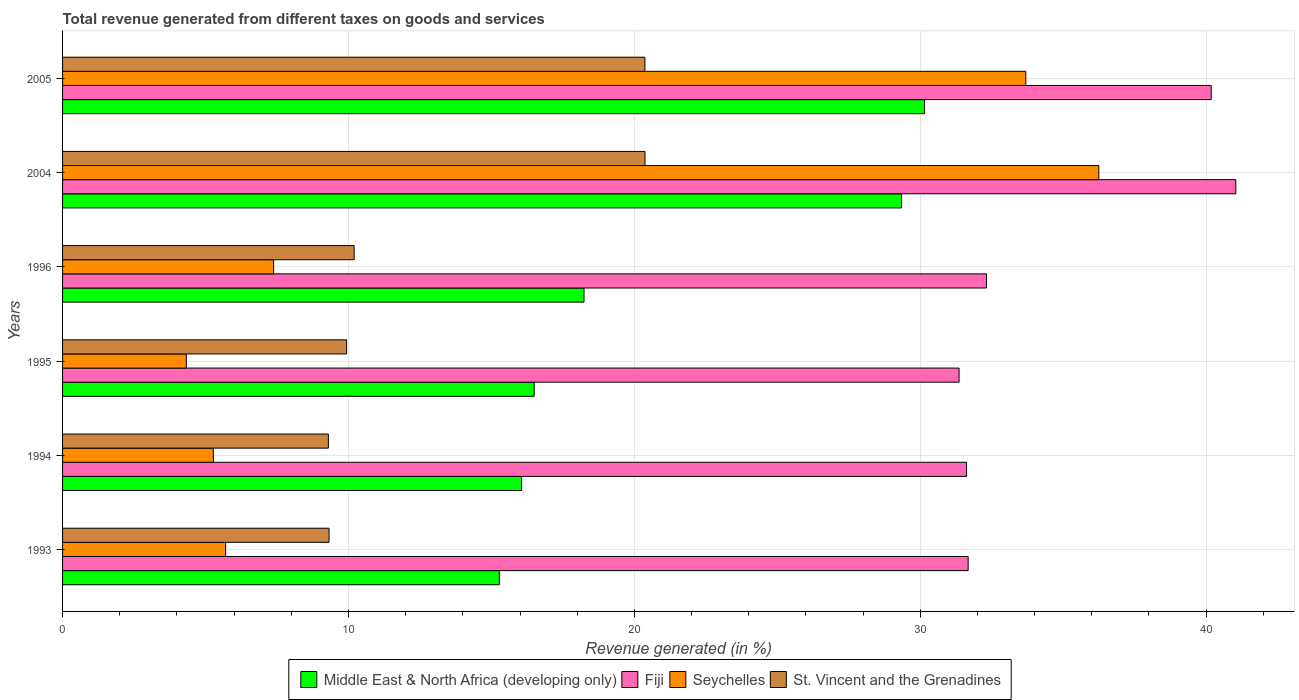How many different coloured bars are there?
Ensure brevity in your answer.  4. What is the total revenue generated in St. Vincent and the Grenadines in 1995?
Offer a terse response. 9.94. Across all years, what is the maximum total revenue generated in Middle East & North Africa (developing only)?
Provide a short and direct response. 30.15. Across all years, what is the minimum total revenue generated in Middle East & North Africa (developing only)?
Provide a succinct answer. 15.28. In which year was the total revenue generated in St. Vincent and the Grenadines maximum?
Offer a terse response. 2004. What is the total total revenue generated in St. Vincent and the Grenadines in the graph?
Your answer should be very brief. 79.5. What is the difference between the total revenue generated in St. Vincent and the Grenadines in 1996 and that in 2005?
Make the answer very short. -10.17. What is the difference between the total revenue generated in Seychelles in 1994 and the total revenue generated in Fiji in 1995?
Your answer should be very brief. -26.08. What is the average total revenue generated in Seychelles per year?
Make the answer very short. 15.44. In the year 1994, what is the difference between the total revenue generated in Fiji and total revenue generated in St. Vincent and the Grenadines?
Make the answer very short. 22.32. What is the ratio of the total revenue generated in Fiji in 1996 to that in 2004?
Provide a short and direct response. 0.79. Is the difference between the total revenue generated in Fiji in 2004 and 2005 greater than the difference between the total revenue generated in St. Vincent and the Grenadines in 2004 and 2005?
Provide a short and direct response. Yes. What is the difference between the highest and the second highest total revenue generated in Fiji?
Provide a succinct answer. 0.86. What is the difference between the highest and the lowest total revenue generated in Middle East & North Africa (developing only)?
Make the answer very short. 14.87. In how many years, is the total revenue generated in Seychelles greater than the average total revenue generated in Seychelles taken over all years?
Keep it short and to the point. 2. Is the sum of the total revenue generated in Seychelles in 1995 and 2004 greater than the maximum total revenue generated in St. Vincent and the Grenadines across all years?
Give a very brief answer. Yes. What does the 2nd bar from the top in 1995 represents?
Your answer should be very brief. Seychelles. What does the 2nd bar from the bottom in 2005 represents?
Make the answer very short. Fiji. Is it the case that in every year, the sum of the total revenue generated in Fiji and total revenue generated in St. Vincent and the Grenadines is greater than the total revenue generated in Seychelles?
Your answer should be compact. Yes. How many bars are there?
Make the answer very short. 24. How many years are there in the graph?
Give a very brief answer. 6. What is the difference between two consecutive major ticks on the X-axis?
Your response must be concise. 10. Does the graph contain any zero values?
Provide a short and direct response. No. Does the graph contain grids?
Keep it short and to the point. Yes. Where does the legend appear in the graph?
Provide a succinct answer. Bottom center. How many legend labels are there?
Your response must be concise. 4. How are the legend labels stacked?
Ensure brevity in your answer.  Horizontal. What is the title of the graph?
Your answer should be very brief. Total revenue generated from different taxes on goods and services. What is the label or title of the X-axis?
Your response must be concise. Revenue generated (in %). What is the label or title of the Y-axis?
Ensure brevity in your answer.  Years. What is the Revenue generated (in %) in Middle East & North Africa (developing only) in 1993?
Ensure brevity in your answer.  15.28. What is the Revenue generated (in %) of Fiji in 1993?
Provide a succinct answer. 31.68. What is the Revenue generated (in %) in Seychelles in 1993?
Your answer should be compact. 5.7. What is the Revenue generated (in %) in St. Vincent and the Grenadines in 1993?
Keep it short and to the point. 9.32. What is the Revenue generated (in %) of Middle East & North Africa (developing only) in 1994?
Give a very brief answer. 16.05. What is the Revenue generated (in %) of Fiji in 1994?
Provide a short and direct response. 31.62. What is the Revenue generated (in %) of Seychelles in 1994?
Offer a terse response. 5.27. What is the Revenue generated (in %) in St. Vincent and the Grenadines in 1994?
Provide a short and direct response. 9.3. What is the Revenue generated (in %) of Middle East & North Africa (developing only) in 1995?
Provide a succinct answer. 16.5. What is the Revenue generated (in %) in Fiji in 1995?
Keep it short and to the point. 31.36. What is the Revenue generated (in %) of Seychelles in 1995?
Keep it short and to the point. 4.33. What is the Revenue generated (in %) in St. Vincent and the Grenadines in 1995?
Offer a very short reply. 9.94. What is the Revenue generated (in %) of Middle East & North Africa (developing only) in 1996?
Give a very brief answer. 18.24. What is the Revenue generated (in %) in Fiji in 1996?
Provide a short and direct response. 32.32. What is the Revenue generated (in %) of Seychelles in 1996?
Your response must be concise. 7.38. What is the Revenue generated (in %) of St. Vincent and the Grenadines in 1996?
Provide a succinct answer. 10.2. What is the Revenue generated (in %) in Middle East & North Africa (developing only) in 2004?
Your response must be concise. 29.35. What is the Revenue generated (in %) in Fiji in 2004?
Provide a succinct answer. 41.04. What is the Revenue generated (in %) of Seychelles in 2004?
Your response must be concise. 36.25. What is the Revenue generated (in %) of St. Vincent and the Grenadines in 2004?
Ensure brevity in your answer.  20.37. What is the Revenue generated (in %) of Middle East & North Africa (developing only) in 2005?
Offer a terse response. 30.15. What is the Revenue generated (in %) in Fiji in 2005?
Give a very brief answer. 40.18. What is the Revenue generated (in %) in Seychelles in 2005?
Give a very brief answer. 33.69. What is the Revenue generated (in %) of St. Vincent and the Grenadines in 2005?
Provide a short and direct response. 20.37. Across all years, what is the maximum Revenue generated (in %) in Middle East & North Africa (developing only)?
Provide a short and direct response. 30.15. Across all years, what is the maximum Revenue generated (in %) in Fiji?
Make the answer very short. 41.04. Across all years, what is the maximum Revenue generated (in %) of Seychelles?
Offer a very short reply. 36.25. Across all years, what is the maximum Revenue generated (in %) in St. Vincent and the Grenadines?
Your answer should be compact. 20.37. Across all years, what is the minimum Revenue generated (in %) in Middle East & North Africa (developing only)?
Provide a succinct answer. 15.28. Across all years, what is the minimum Revenue generated (in %) in Fiji?
Keep it short and to the point. 31.36. Across all years, what is the minimum Revenue generated (in %) of Seychelles?
Ensure brevity in your answer.  4.33. Across all years, what is the minimum Revenue generated (in %) of St. Vincent and the Grenadines?
Offer a very short reply. 9.3. What is the total Revenue generated (in %) of Middle East & North Africa (developing only) in the graph?
Offer a terse response. 125.57. What is the total Revenue generated (in %) in Fiji in the graph?
Give a very brief answer. 208.18. What is the total Revenue generated (in %) in Seychelles in the graph?
Your answer should be very brief. 92.63. What is the total Revenue generated (in %) of St. Vincent and the Grenadines in the graph?
Your answer should be compact. 79.5. What is the difference between the Revenue generated (in %) of Middle East & North Africa (developing only) in 1993 and that in 1994?
Make the answer very short. -0.78. What is the difference between the Revenue generated (in %) in Fiji in 1993 and that in 1994?
Your answer should be compact. 0.06. What is the difference between the Revenue generated (in %) in Seychelles in 1993 and that in 1994?
Keep it short and to the point. 0.43. What is the difference between the Revenue generated (in %) in St. Vincent and the Grenadines in 1993 and that in 1994?
Offer a terse response. 0.02. What is the difference between the Revenue generated (in %) of Middle East & North Africa (developing only) in 1993 and that in 1995?
Your answer should be compact. -1.22. What is the difference between the Revenue generated (in %) in Fiji in 1993 and that in 1995?
Ensure brevity in your answer.  0.32. What is the difference between the Revenue generated (in %) in Seychelles in 1993 and that in 1995?
Offer a terse response. 1.37. What is the difference between the Revenue generated (in %) in St. Vincent and the Grenadines in 1993 and that in 1995?
Offer a terse response. -0.61. What is the difference between the Revenue generated (in %) in Middle East & North Africa (developing only) in 1993 and that in 1996?
Make the answer very short. -2.96. What is the difference between the Revenue generated (in %) of Fiji in 1993 and that in 1996?
Offer a very short reply. -0.64. What is the difference between the Revenue generated (in %) of Seychelles in 1993 and that in 1996?
Your answer should be very brief. -1.68. What is the difference between the Revenue generated (in %) of St. Vincent and the Grenadines in 1993 and that in 1996?
Give a very brief answer. -0.88. What is the difference between the Revenue generated (in %) in Middle East & North Africa (developing only) in 1993 and that in 2004?
Ensure brevity in your answer.  -14.07. What is the difference between the Revenue generated (in %) of Fiji in 1993 and that in 2004?
Ensure brevity in your answer.  -9.36. What is the difference between the Revenue generated (in %) in Seychelles in 1993 and that in 2004?
Ensure brevity in your answer.  -30.54. What is the difference between the Revenue generated (in %) in St. Vincent and the Grenadines in 1993 and that in 2004?
Offer a terse response. -11.05. What is the difference between the Revenue generated (in %) in Middle East & North Africa (developing only) in 1993 and that in 2005?
Offer a very short reply. -14.87. What is the difference between the Revenue generated (in %) of Fiji in 1993 and that in 2005?
Ensure brevity in your answer.  -8.5. What is the difference between the Revenue generated (in %) of Seychelles in 1993 and that in 2005?
Offer a terse response. -27.99. What is the difference between the Revenue generated (in %) in St. Vincent and the Grenadines in 1993 and that in 2005?
Provide a short and direct response. -11.05. What is the difference between the Revenue generated (in %) of Middle East & North Africa (developing only) in 1994 and that in 1995?
Ensure brevity in your answer.  -0.44. What is the difference between the Revenue generated (in %) in Fiji in 1994 and that in 1995?
Your answer should be compact. 0.26. What is the difference between the Revenue generated (in %) in Seychelles in 1994 and that in 1995?
Make the answer very short. 0.95. What is the difference between the Revenue generated (in %) in St. Vincent and the Grenadines in 1994 and that in 1995?
Provide a short and direct response. -0.64. What is the difference between the Revenue generated (in %) in Middle East & North Africa (developing only) in 1994 and that in 1996?
Make the answer very short. -2.19. What is the difference between the Revenue generated (in %) of Fiji in 1994 and that in 1996?
Your answer should be compact. -0.7. What is the difference between the Revenue generated (in %) in Seychelles in 1994 and that in 1996?
Your answer should be very brief. -2.11. What is the difference between the Revenue generated (in %) of St. Vincent and the Grenadines in 1994 and that in 1996?
Make the answer very short. -0.9. What is the difference between the Revenue generated (in %) in Middle East & North Africa (developing only) in 1994 and that in 2004?
Provide a short and direct response. -13.29. What is the difference between the Revenue generated (in %) in Fiji in 1994 and that in 2004?
Your answer should be compact. -9.42. What is the difference between the Revenue generated (in %) of Seychelles in 1994 and that in 2004?
Keep it short and to the point. -30.97. What is the difference between the Revenue generated (in %) of St. Vincent and the Grenadines in 1994 and that in 2004?
Make the answer very short. -11.07. What is the difference between the Revenue generated (in %) of Middle East & North Africa (developing only) in 1994 and that in 2005?
Provide a succinct answer. -14.1. What is the difference between the Revenue generated (in %) of Fiji in 1994 and that in 2005?
Your response must be concise. -8.56. What is the difference between the Revenue generated (in %) in Seychelles in 1994 and that in 2005?
Offer a very short reply. -28.42. What is the difference between the Revenue generated (in %) in St. Vincent and the Grenadines in 1994 and that in 2005?
Make the answer very short. -11.07. What is the difference between the Revenue generated (in %) in Middle East & North Africa (developing only) in 1995 and that in 1996?
Ensure brevity in your answer.  -1.74. What is the difference between the Revenue generated (in %) of Fiji in 1995 and that in 1996?
Your answer should be compact. -0.96. What is the difference between the Revenue generated (in %) of Seychelles in 1995 and that in 1996?
Your answer should be very brief. -3.05. What is the difference between the Revenue generated (in %) in St. Vincent and the Grenadines in 1995 and that in 1996?
Your answer should be very brief. -0.26. What is the difference between the Revenue generated (in %) of Middle East & North Africa (developing only) in 1995 and that in 2004?
Provide a short and direct response. -12.85. What is the difference between the Revenue generated (in %) of Fiji in 1995 and that in 2004?
Your answer should be very brief. -9.68. What is the difference between the Revenue generated (in %) in Seychelles in 1995 and that in 2004?
Ensure brevity in your answer.  -31.92. What is the difference between the Revenue generated (in %) in St. Vincent and the Grenadines in 1995 and that in 2004?
Ensure brevity in your answer.  -10.44. What is the difference between the Revenue generated (in %) in Middle East & North Africa (developing only) in 1995 and that in 2005?
Provide a short and direct response. -13.65. What is the difference between the Revenue generated (in %) in Fiji in 1995 and that in 2005?
Provide a short and direct response. -8.82. What is the difference between the Revenue generated (in %) of Seychelles in 1995 and that in 2005?
Your answer should be very brief. -29.36. What is the difference between the Revenue generated (in %) in St. Vincent and the Grenadines in 1995 and that in 2005?
Offer a terse response. -10.43. What is the difference between the Revenue generated (in %) of Middle East & North Africa (developing only) in 1996 and that in 2004?
Give a very brief answer. -11.11. What is the difference between the Revenue generated (in %) in Fiji in 1996 and that in 2004?
Your response must be concise. -8.72. What is the difference between the Revenue generated (in %) in Seychelles in 1996 and that in 2004?
Ensure brevity in your answer.  -28.86. What is the difference between the Revenue generated (in %) of St. Vincent and the Grenadines in 1996 and that in 2004?
Offer a very short reply. -10.17. What is the difference between the Revenue generated (in %) of Middle East & North Africa (developing only) in 1996 and that in 2005?
Ensure brevity in your answer.  -11.91. What is the difference between the Revenue generated (in %) of Fiji in 1996 and that in 2005?
Make the answer very short. -7.86. What is the difference between the Revenue generated (in %) in Seychelles in 1996 and that in 2005?
Provide a short and direct response. -26.31. What is the difference between the Revenue generated (in %) in St. Vincent and the Grenadines in 1996 and that in 2005?
Your answer should be compact. -10.17. What is the difference between the Revenue generated (in %) of Middle East & North Africa (developing only) in 2004 and that in 2005?
Provide a succinct answer. -0.8. What is the difference between the Revenue generated (in %) of Fiji in 2004 and that in 2005?
Provide a short and direct response. 0.86. What is the difference between the Revenue generated (in %) in Seychelles in 2004 and that in 2005?
Provide a short and direct response. 2.55. What is the difference between the Revenue generated (in %) of St. Vincent and the Grenadines in 2004 and that in 2005?
Provide a short and direct response. 0. What is the difference between the Revenue generated (in %) of Middle East & North Africa (developing only) in 1993 and the Revenue generated (in %) of Fiji in 1994?
Your answer should be very brief. -16.34. What is the difference between the Revenue generated (in %) of Middle East & North Africa (developing only) in 1993 and the Revenue generated (in %) of Seychelles in 1994?
Provide a short and direct response. 10. What is the difference between the Revenue generated (in %) of Middle East & North Africa (developing only) in 1993 and the Revenue generated (in %) of St. Vincent and the Grenadines in 1994?
Your answer should be very brief. 5.98. What is the difference between the Revenue generated (in %) of Fiji in 1993 and the Revenue generated (in %) of Seychelles in 1994?
Ensure brevity in your answer.  26.4. What is the difference between the Revenue generated (in %) in Fiji in 1993 and the Revenue generated (in %) in St. Vincent and the Grenadines in 1994?
Keep it short and to the point. 22.38. What is the difference between the Revenue generated (in %) of Seychelles in 1993 and the Revenue generated (in %) of St. Vincent and the Grenadines in 1994?
Provide a short and direct response. -3.59. What is the difference between the Revenue generated (in %) in Middle East & North Africa (developing only) in 1993 and the Revenue generated (in %) in Fiji in 1995?
Keep it short and to the point. -16.08. What is the difference between the Revenue generated (in %) of Middle East & North Africa (developing only) in 1993 and the Revenue generated (in %) of Seychelles in 1995?
Give a very brief answer. 10.95. What is the difference between the Revenue generated (in %) of Middle East & North Africa (developing only) in 1993 and the Revenue generated (in %) of St. Vincent and the Grenadines in 1995?
Provide a short and direct response. 5.34. What is the difference between the Revenue generated (in %) in Fiji in 1993 and the Revenue generated (in %) in Seychelles in 1995?
Provide a short and direct response. 27.35. What is the difference between the Revenue generated (in %) in Fiji in 1993 and the Revenue generated (in %) in St. Vincent and the Grenadines in 1995?
Provide a short and direct response. 21.74. What is the difference between the Revenue generated (in %) of Seychelles in 1993 and the Revenue generated (in %) of St. Vincent and the Grenadines in 1995?
Keep it short and to the point. -4.23. What is the difference between the Revenue generated (in %) in Middle East & North Africa (developing only) in 1993 and the Revenue generated (in %) in Fiji in 1996?
Make the answer very short. -17.04. What is the difference between the Revenue generated (in %) of Middle East & North Africa (developing only) in 1993 and the Revenue generated (in %) of Seychelles in 1996?
Keep it short and to the point. 7.9. What is the difference between the Revenue generated (in %) of Middle East & North Africa (developing only) in 1993 and the Revenue generated (in %) of St. Vincent and the Grenadines in 1996?
Your response must be concise. 5.08. What is the difference between the Revenue generated (in %) of Fiji in 1993 and the Revenue generated (in %) of Seychelles in 1996?
Ensure brevity in your answer.  24.29. What is the difference between the Revenue generated (in %) in Fiji in 1993 and the Revenue generated (in %) in St. Vincent and the Grenadines in 1996?
Your answer should be compact. 21.48. What is the difference between the Revenue generated (in %) of Seychelles in 1993 and the Revenue generated (in %) of St. Vincent and the Grenadines in 1996?
Provide a succinct answer. -4.5. What is the difference between the Revenue generated (in %) of Middle East & North Africa (developing only) in 1993 and the Revenue generated (in %) of Fiji in 2004?
Make the answer very short. -25.76. What is the difference between the Revenue generated (in %) of Middle East & North Africa (developing only) in 1993 and the Revenue generated (in %) of Seychelles in 2004?
Provide a succinct answer. -20.97. What is the difference between the Revenue generated (in %) in Middle East & North Africa (developing only) in 1993 and the Revenue generated (in %) in St. Vincent and the Grenadines in 2004?
Give a very brief answer. -5.09. What is the difference between the Revenue generated (in %) in Fiji in 1993 and the Revenue generated (in %) in Seychelles in 2004?
Offer a very short reply. -4.57. What is the difference between the Revenue generated (in %) in Fiji in 1993 and the Revenue generated (in %) in St. Vincent and the Grenadines in 2004?
Your answer should be very brief. 11.3. What is the difference between the Revenue generated (in %) in Seychelles in 1993 and the Revenue generated (in %) in St. Vincent and the Grenadines in 2004?
Your response must be concise. -14.67. What is the difference between the Revenue generated (in %) of Middle East & North Africa (developing only) in 1993 and the Revenue generated (in %) of Fiji in 2005?
Ensure brevity in your answer.  -24.9. What is the difference between the Revenue generated (in %) in Middle East & North Africa (developing only) in 1993 and the Revenue generated (in %) in Seychelles in 2005?
Offer a terse response. -18.41. What is the difference between the Revenue generated (in %) of Middle East & North Africa (developing only) in 1993 and the Revenue generated (in %) of St. Vincent and the Grenadines in 2005?
Your answer should be very brief. -5.09. What is the difference between the Revenue generated (in %) in Fiji in 1993 and the Revenue generated (in %) in Seychelles in 2005?
Your answer should be very brief. -2.02. What is the difference between the Revenue generated (in %) in Fiji in 1993 and the Revenue generated (in %) in St. Vincent and the Grenadines in 2005?
Keep it short and to the point. 11.31. What is the difference between the Revenue generated (in %) of Seychelles in 1993 and the Revenue generated (in %) of St. Vincent and the Grenadines in 2005?
Offer a very short reply. -14.67. What is the difference between the Revenue generated (in %) of Middle East & North Africa (developing only) in 1994 and the Revenue generated (in %) of Fiji in 1995?
Provide a short and direct response. -15.3. What is the difference between the Revenue generated (in %) in Middle East & North Africa (developing only) in 1994 and the Revenue generated (in %) in Seychelles in 1995?
Give a very brief answer. 11.73. What is the difference between the Revenue generated (in %) of Middle East & North Africa (developing only) in 1994 and the Revenue generated (in %) of St. Vincent and the Grenadines in 1995?
Provide a succinct answer. 6.12. What is the difference between the Revenue generated (in %) in Fiji in 1994 and the Revenue generated (in %) in Seychelles in 1995?
Your answer should be very brief. 27.29. What is the difference between the Revenue generated (in %) of Fiji in 1994 and the Revenue generated (in %) of St. Vincent and the Grenadines in 1995?
Give a very brief answer. 21.68. What is the difference between the Revenue generated (in %) in Seychelles in 1994 and the Revenue generated (in %) in St. Vincent and the Grenadines in 1995?
Your answer should be compact. -4.66. What is the difference between the Revenue generated (in %) of Middle East & North Africa (developing only) in 1994 and the Revenue generated (in %) of Fiji in 1996?
Your answer should be very brief. -16.26. What is the difference between the Revenue generated (in %) in Middle East & North Africa (developing only) in 1994 and the Revenue generated (in %) in Seychelles in 1996?
Make the answer very short. 8.67. What is the difference between the Revenue generated (in %) in Middle East & North Africa (developing only) in 1994 and the Revenue generated (in %) in St. Vincent and the Grenadines in 1996?
Offer a very short reply. 5.86. What is the difference between the Revenue generated (in %) in Fiji in 1994 and the Revenue generated (in %) in Seychelles in 1996?
Offer a very short reply. 24.23. What is the difference between the Revenue generated (in %) in Fiji in 1994 and the Revenue generated (in %) in St. Vincent and the Grenadines in 1996?
Your response must be concise. 21.42. What is the difference between the Revenue generated (in %) in Seychelles in 1994 and the Revenue generated (in %) in St. Vincent and the Grenadines in 1996?
Your answer should be compact. -4.93. What is the difference between the Revenue generated (in %) in Middle East & North Africa (developing only) in 1994 and the Revenue generated (in %) in Fiji in 2004?
Your response must be concise. -24.98. What is the difference between the Revenue generated (in %) of Middle East & North Africa (developing only) in 1994 and the Revenue generated (in %) of Seychelles in 2004?
Make the answer very short. -20.19. What is the difference between the Revenue generated (in %) in Middle East & North Africa (developing only) in 1994 and the Revenue generated (in %) in St. Vincent and the Grenadines in 2004?
Provide a succinct answer. -4.32. What is the difference between the Revenue generated (in %) of Fiji in 1994 and the Revenue generated (in %) of Seychelles in 2004?
Provide a short and direct response. -4.63. What is the difference between the Revenue generated (in %) in Fiji in 1994 and the Revenue generated (in %) in St. Vincent and the Grenadines in 2004?
Ensure brevity in your answer.  11.24. What is the difference between the Revenue generated (in %) of Seychelles in 1994 and the Revenue generated (in %) of St. Vincent and the Grenadines in 2004?
Provide a succinct answer. -15.1. What is the difference between the Revenue generated (in %) in Middle East & North Africa (developing only) in 1994 and the Revenue generated (in %) in Fiji in 2005?
Your answer should be compact. -24.12. What is the difference between the Revenue generated (in %) in Middle East & North Africa (developing only) in 1994 and the Revenue generated (in %) in Seychelles in 2005?
Your answer should be very brief. -17.64. What is the difference between the Revenue generated (in %) of Middle East & North Africa (developing only) in 1994 and the Revenue generated (in %) of St. Vincent and the Grenadines in 2005?
Offer a very short reply. -4.32. What is the difference between the Revenue generated (in %) in Fiji in 1994 and the Revenue generated (in %) in Seychelles in 2005?
Provide a succinct answer. -2.08. What is the difference between the Revenue generated (in %) of Fiji in 1994 and the Revenue generated (in %) of St. Vincent and the Grenadines in 2005?
Your answer should be very brief. 11.25. What is the difference between the Revenue generated (in %) of Seychelles in 1994 and the Revenue generated (in %) of St. Vincent and the Grenadines in 2005?
Provide a succinct answer. -15.1. What is the difference between the Revenue generated (in %) of Middle East & North Africa (developing only) in 1995 and the Revenue generated (in %) of Fiji in 1996?
Give a very brief answer. -15.82. What is the difference between the Revenue generated (in %) of Middle East & North Africa (developing only) in 1995 and the Revenue generated (in %) of Seychelles in 1996?
Make the answer very short. 9.11. What is the difference between the Revenue generated (in %) of Middle East & North Africa (developing only) in 1995 and the Revenue generated (in %) of St. Vincent and the Grenadines in 1996?
Your answer should be compact. 6.3. What is the difference between the Revenue generated (in %) in Fiji in 1995 and the Revenue generated (in %) in Seychelles in 1996?
Your answer should be very brief. 23.98. What is the difference between the Revenue generated (in %) in Fiji in 1995 and the Revenue generated (in %) in St. Vincent and the Grenadines in 1996?
Your answer should be very brief. 21.16. What is the difference between the Revenue generated (in %) in Seychelles in 1995 and the Revenue generated (in %) in St. Vincent and the Grenadines in 1996?
Provide a succinct answer. -5.87. What is the difference between the Revenue generated (in %) of Middle East & North Africa (developing only) in 1995 and the Revenue generated (in %) of Fiji in 2004?
Ensure brevity in your answer.  -24.54. What is the difference between the Revenue generated (in %) of Middle East & North Africa (developing only) in 1995 and the Revenue generated (in %) of Seychelles in 2004?
Keep it short and to the point. -19.75. What is the difference between the Revenue generated (in %) in Middle East & North Africa (developing only) in 1995 and the Revenue generated (in %) in St. Vincent and the Grenadines in 2004?
Give a very brief answer. -3.88. What is the difference between the Revenue generated (in %) of Fiji in 1995 and the Revenue generated (in %) of Seychelles in 2004?
Offer a terse response. -4.89. What is the difference between the Revenue generated (in %) in Fiji in 1995 and the Revenue generated (in %) in St. Vincent and the Grenadines in 2004?
Make the answer very short. 10.99. What is the difference between the Revenue generated (in %) in Seychelles in 1995 and the Revenue generated (in %) in St. Vincent and the Grenadines in 2004?
Ensure brevity in your answer.  -16.04. What is the difference between the Revenue generated (in %) in Middle East & North Africa (developing only) in 1995 and the Revenue generated (in %) in Fiji in 2005?
Ensure brevity in your answer.  -23.68. What is the difference between the Revenue generated (in %) in Middle East & North Africa (developing only) in 1995 and the Revenue generated (in %) in Seychelles in 2005?
Your response must be concise. -17.2. What is the difference between the Revenue generated (in %) in Middle East & North Africa (developing only) in 1995 and the Revenue generated (in %) in St. Vincent and the Grenadines in 2005?
Your answer should be very brief. -3.87. What is the difference between the Revenue generated (in %) of Fiji in 1995 and the Revenue generated (in %) of Seychelles in 2005?
Provide a succinct answer. -2.33. What is the difference between the Revenue generated (in %) of Fiji in 1995 and the Revenue generated (in %) of St. Vincent and the Grenadines in 2005?
Provide a short and direct response. 10.99. What is the difference between the Revenue generated (in %) of Seychelles in 1995 and the Revenue generated (in %) of St. Vincent and the Grenadines in 2005?
Your answer should be very brief. -16.04. What is the difference between the Revenue generated (in %) in Middle East & North Africa (developing only) in 1996 and the Revenue generated (in %) in Fiji in 2004?
Ensure brevity in your answer.  -22.8. What is the difference between the Revenue generated (in %) of Middle East & North Africa (developing only) in 1996 and the Revenue generated (in %) of Seychelles in 2004?
Your answer should be compact. -18.01. What is the difference between the Revenue generated (in %) of Middle East & North Africa (developing only) in 1996 and the Revenue generated (in %) of St. Vincent and the Grenadines in 2004?
Your answer should be very brief. -2.13. What is the difference between the Revenue generated (in %) of Fiji in 1996 and the Revenue generated (in %) of Seychelles in 2004?
Provide a short and direct response. -3.93. What is the difference between the Revenue generated (in %) of Fiji in 1996 and the Revenue generated (in %) of St. Vincent and the Grenadines in 2004?
Provide a succinct answer. 11.94. What is the difference between the Revenue generated (in %) of Seychelles in 1996 and the Revenue generated (in %) of St. Vincent and the Grenadines in 2004?
Offer a very short reply. -12.99. What is the difference between the Revenue generated (in %) in Middle East & North Africa (developing only) in 1996 and the Revenue generated (in %) in Fiji in 2005?
Your response must be concise. -21.94. What is the difference between the Revenue generated (in %) in Middle East & North Africa (developing only) in 1996 and the Revenue generated (in %) in Seychelles in 2005?
Give a very brief answer. -15.45. What is the difference between the Revenue generated (in %) of Middle East & North Africa (developing only) in 1996 and the Revenue generated (in %) of St. Vincent and the Grenadines in 2005?
Make the answer very short. -2.13. What is the difference between the Revenue generated (in %) in Fiji in 1996 and the Revenue generated (in %) in Seychelles in 2005?
Give a very brief answer. -1.38. What is the difference between the Revenue generated (in %) of Fiji in 1996 and the Revenue generated (in %) of St. Vincent and the Grenadines in 2005?
Give a very brief answer. 11.95. What is the difference between the Revenue generated (in %) in Seychelles in 1996 and the Revenue generated (in %) in St. Vincent and the Grenadines in 2005?
Ensure brevity in your answer.  -12.99. What is the difference between the Revenue generated (in %) of Middle East & North Africa (developing only) in 2004 and the Revenue generated (in %) of Fiji in 2005?
Offer a very short reply. -10.83. What is the difference between the Revenue generated (in %) in Middle East & North Africa (developing only) in 2004 and the Revenue generated (in %) in Seychelles in 2005?
Give a very brief answer. -4.34. What is the difference between the Revenue generated (in %) in Middle East & North Africa (developing only) in 2004 and the Revenue generated (in %) in St. Vincent and the Grenadines in 2005?
Provide a short and direct response. 8.98. What is the difference between the Revenue generated (in %) in Fiji in 2004 and the Revenue generated (in %) in Seychelles in 2005?
Your answer should be very brief. 7.35. What is the difference between the Revenue generated (in %) of Fiji in 2004 and the Revenue generated (in %) of St. Vincent and the Grenadines in 2005?
Give a very brief answer. 20.67. What is the difference between the Revenue generated (in %) in Seychelles in 2004 and the Revenue generated (in %) in St. Vincent and the Grenadines in 2005?
Ensure brevity in your answer.  15.88. What is the average Revenue generated (in %) of Middle East & North Africa (developing only) per year?
Keep it short and to the point. 20.93. What is the average Revenue generated (in %) of Fiji per year?
Provide a short and direct response. 34.7. What is the average Revenue generated (in %) in Seychelles per year?
Ensure brevity in your answer.  15.44. What is the average Revenue generated (in %) of St. Vincent and the Grenadines per year?
Offer a very short reply. 13.25. In the year 1993, what is the difference between the Revenue generated (in %) of Middle East & North Africa (developing only) and Revenue generated (in %) of Fiji?
Offer a terse response. -16.4. In the year 1993, what is the difference between the Revenue generated (in %) in Middle East & North Africa (developing only) and Revenue generated (in %) in Seychelles?
Provide a short and direct response. 9.57. In the year 1993, what is the difference between the Revenue generated (in %) in Middle East & North Africa (developing only) and Revenue generated (in %) in St. Vincent and the Grenadines?
Keep it short and to the point. 5.96. In the year 1993, what is the difference between the Revenue generated (in %) of Fiji and Revenue generated (in %) of Seychelles?
Offer a very short reply. 25.97. In the year 1993, what is the difference between the Revenue generated (in %) of Fiji and Revenue generated (in %) of St. Vincent and the Grenadines?
Provide a short and direct response. 22.35. In the year 1993, what is the difference between the Revenue generated (in %) in Seychelles and Revenue generated (in %) in St. Vincent and the Grenadines?
Keep it short and to the point. -3.62. In the year 1994, what is the difference between the Revenue generated (in %) in Middle East & North Africa (developing only) and Revenue generated (in %) in Fiji?
Ensure brevity in your answer.  -15.56. In the year 1994, what is the difference between the Revenue generated (in %) in Middle East & North Africa (developing only) and Revenue generated (in %) in Seychelles?
Your response must be concise. 10.78. In the year 1994, what is the difference between the Revenue generated (in %) of Middle East & North Africa (developing only) and Revenue generated (in %) of St. Vincent and the Grenadines?
Give a very brief answer. 6.76. In the year 1994, what is the difference between the Revenue generated (in %) of Fiji and Revenue generated (in %) of Seychelles?
Provide a succinct answer. 26.34. In the year 1994, what is the difference between the Revenue generated (in %) of Fiji and Revenue generated (in %) of St. Vincent and the Grenadines?
Your answer should be compact. 22.32. In the year 1994, what is the difference between the Revenue generated (in %) of Seychelles and Revenue generated (in %) of St. Vincent and the Grenadines?
Your answer should be very brief. -4.02. In the year 1995, what is the difference between the Revenue generated (in %) in Middle East & North Africa (developing only) and Revenue generated (in %) in Fiji?
Give a very brief answer. -14.86. In the year 1995, what is the difference between the Revenue generated (in %) of Middle East & North Africa (developing only) and Revenue generated (in %) of Seychelles?
Offer a very short reply. 12.17. In the year 1995, what is the difference between the Revenue generated (in %) in Middle East & North Africa (developing only) and Revenue generated (in %) in St. Vincent and the Grenadines?
Your answer should be very brief. 6.56. In the year 1995, what is the difference between the Revenue generated (in %) in Fiji and Revenue generated (in %) in Seychelles?
Provide a succinct answer. 27.03. In the year 1995, what is the difference between the Revenue generated (in %) in Fiji and Revenue generated (in %) in St. Vincent and the Grenadines?
Provide a succinct answer. 21.42. In the year 1995, what is the difference between the Revenue generated (in %) of Seychelles and Revenue generated (in %) of St. Vincent and the Grenadines?
Make the answer very short. -5.61. In the year 1996, what is the difference between the Revenue generated (in %) in Middle East & North Africa (developing only) and Revenue generated (in %) in Fiji?
Keep it short and to the point. -14.08. In the year 1996, what is the difference between the Revenue generated (in %) in Middle East & North Africa (developing only) and Revenue generated (in %) in Seychelles?
Give a very brief answer. 10.86. In the year 1996, what is the difference between the Revenue generated (in %) in Middle East & North Africa (developing only) and Revenue generated (in %) in St. Vincent and the Grenadines?
Keep it short and to the point. 8.04. In the year 1996, what is the difference between the Revenue generated (in %) of Fiji and Revenue generated (in %) of Seychelles?
Provide a short and direct response. 24.94. In the year 1996, what is the difference between the Revenue generated (in %) of Fiji and Revenue generated (in %) of St. Vincent and the Grenadines?
Your response must be concise. 22.12. In the year 1996, what is the difference between the Revenue generated (in %) of Seychelles and Revenue generated (in %) of St. Vincent and the Grenadines?
Your response must be concise. -2.82. In the year 2004, what is the difference between the Revenue generated (in %) in Middle East & North Africa (developing only) and Revenue generated (in %) in Fiji?
Provide a succinct answer. -11.69. In the year 2004, what is the difference between the Revenue generated (in %) of Middle East & North Africa (developing only) and Revenue generated (in %) of Seychelles?
Give a very brief answer. -6.9. In the year 2004, what is the difference between the Revenue generated (in %) of Middle East & North Africa (developing only) and Revenue generated (in %) of St. Vincent and the Grenadines?
Provide a succinct answer. 8.97. In the year 2004, what is the difference between the Revenue generated (in %) in Fiji and Revenue generated (in %) in Seychelles?
Your answer should be very brief. 4.79. In the year 2004, what is the difference between the Revenue generated (in %) of Fiji and Revenue generated (in %) of St. Vincent and the Grenadines?
Ensure brevity in your answer.  20.67. In the year 2004, what is the difference between the Revenue generated (in %) in Seychelles and Revenue generated (in %) in St. Vincent and the Grenadines?
Your answer should be very brief. 15.87. In the year 2005, what is the difference between the Revenue generated (in %) in Middle East & North Africa (developing only) and Revenue generated (in %) in Fiji?
Provide a short and direct response. -10.03. In the year 2005, what is the difference between the Revenue generated (in %) in Middle East & North Africa (developing only) and Revenue generated (in %) in Seychelles?
Provide a succinct answer. -3.54. In the year 2005, what is the difference between the Revenue generated (in %) in Middle East & North Africa (developing only) and Revenue generated (in %) in St. Vincent and the Grenadines?
Give a very brief answer. 9.78. In the year 2005, what is the difference between the Revenue generated (in %) of Fiji and Revenue generated (in %) of Seychelles?
Offer a very short reply. 6.48. In the year 2005, what is the difference between the Revenue generated (in %) in Fiji and Revenue generated (in %) in St. Vincent and the Grenadines?
Make the answer very short. 19.81. In the year 2005, what is the difference between the Revenue generated (in %) of Seychelles and Revenue generated (in %) of St. Vincent and the Grenadines?
Ensure brevity in your answer.  13.32. What is the ratio of the Revenue generated (in %) in Middle East & North Africa (developing only) in 1993 to that in 1994?
Your answer should be compact. 0.95. What is the ratio of the Revenue generated (in %) in Seychelles in 1993 to that in 1994?
Provide a short and direct response. 1.08. What is the ratio of the Revenue generated (in %) in St. Vincent and the Grenadines in 1993 to that in 1994?
Give a very brief answer. 1. What is the ratio of the Revenue generated (in %) of Middle East & North Africa (developing only) in 1993 to that in 1995?
Give a very brief answer. 0.93. What is the ratio of the Revenue generated (in %) of Seychelles in 1993 to that in 1995?
Offer a terse response. 1.32. What is the ratio of the Revenue generated (in %) in St. Vincent and the Grenadines in 1993 to that in 1995?
Offer a very short reply. 0.94. What is the ratio of the Revenue generated (in %) of Middle East & North Africa (developing only) in 1993 to that in 1996?
Ensure brevity in your answer.  0.84. What is the ratio of the Revenue generated (in %) in Fiji in 1993 to that in 1996?
Your response must be concise. 0.98. What is the ratio of the Revenue generated (in %) in Seychelles in 1993 to that in 1996?
Make the answer very short. 0.77. What is the ratio of the Revenue generated (in %) in St. Vincent and the Grenadines in 1993 to that in 1996?
Offer a terse response. 0.91. What is the ratio of the Revenue generated (in %) of Middle East & North Africa (developing only) in 1993 to that in 2004?
Offer a very short reply. 0.52. What is the ratio of the Revenue generated (in %) in Fiji in 1993 to that in 2004?
Offer a terse response. 0.77. What is the ratio of the Revenue generated (in %) in Seychelles in 1993 to that in 2004?
Ensure brevity in your answer.  0.16. What is the ratio of the Revenue generated (in %) of St. Vincent and the Grenadines in 1993 to that in 2004?
Your answer should be very brief. 0.46. What is the ratio of the Revenue generated (in %) in Middle East & North Africa (developing only) in 1993 to that in 2005?
Your answer should be very brief. 0.51. What is the ratio of the Revenue generated (in %) of Fiji in 1993 to that in 2005?
Your answer should be very brief. 0.79. What is the ratio of the Revenue generated (in %) in Seychelles in 1993 to that in 2005?
Give a very brief answer. 0.17. What is the ratio of the Revenue generated (in %) in St. Vincent and the Grenadines in 1993 to that in 2005?
Offer a terse response. 0.46. What is the ratio of the Revenue generated (in %) in Middle East & North Africa (developing only) in 1994 to that in 1995?
Your response must be concise. 0.97. What is the ratio of the Revenue generated (in %) of Fiji in 1994 to that in 1995?
Provide a succinct answer. 1.01. What is the ratio of the Revenue generated (in %) in Seychelles in 1994 to that in 1995?
Provide a succinct answer. 1.22. What is the ratio of the Revenue generated (in %) in St. Vincent and the Grenadines in 1994 to that in 1995?
Offer a very short reply. 0.94. What is the ratio of the Revenue generated (in %) of Middle East & North Africa (developing only) in 1994 to that in 1996?
Keep it short and to the point. 0.88. What is the ratio of the Revenue generated (in %) of Fiji in 1994 to that in 1996?
Ensure brevity in your answer.  0.98. What is the ratio of the Revenue generated (in %) in Seychelles in 1994 to that in 1996?
Provide a short and direct response. 0.71. What is the ratio of the Revenue generated (in %) in St. Vincent and the Grenadines in 1994 to that in 1996?
Your answer should be compact. 0.91. What is the ratio of the Revenue generated (in %) of Middle East & North Africa (developing only) in 1994 to that in 2004?
Your answer should be very brief. 0.55. What is the ratio of the Revenue generated (in %) in Fiji in 1994 to that in 2004?
Make the answer very short. 0.77. What is the ratio of the Revenue generated (in %) in Seychelles in 1994 to that in 2004?
Offer a terse response. 0.15. What is the ratio of the Revenue generated (in %) in St. Vincent and the Grenadines in 1994 to that in 2004?
Offer a very short reply. 0.46. What is the ratio of the Revenue generated (in %) of Middle East & North Africa (developing only) in 1994 to that in 2005?
Provide a short and direct response. 0.53. What is the ratio of the Revenue generated (in %) of Fiji in 1994 to that in 2005?
Offer a terse response. 0.79. What is the ratio of the Revenue generated (in %) of Seychelles in 1994 to that in 2005?
Provide a short and direct response. 0.16. What is the ratio of the Revenue generated (in %) of St. Vincent and the Grenadines in 1994 to that in 2005?
Offer a terse response. 0.46. What is the ratio of the Revenue generated (in %) of Middle East & North Africa (developing only) in 1995 to that in 1996?
Ensure brevity in your answer.  0.9. What is the ratio of the Revenue generated (in %) in Fiji in 1995 to that in 1996?
Your answer should be very brief. 0.97. What is the ratio of the Revenue generated (in %) in Seychelles in 1995 to that in 1996?
Give a very brief answer. 0.59. What is the ratio of the Revenue generated (in %) in St. Vincent and the Grenadines in 1995 to that in 1996?
Offer a very short reply. 0.97. What is the ratio of the Revenue generated (in %) of Middle East & North Africa (developing only) in 1995 to that in 2004?
Give a very brief answer. 0.56. What is the ratio of the Revenue generated (in %) of Fiji in 1995 to that in 2004?
Provide a succinct answer. 0.76. What is the ratio of the Revenue generated (in %) of Seychelles in 1995 to that in 2004?
Offer a terse response. 0.12. What is the ratio of the Revenue generated (in %) in St. Vincent and the Grenadines in 1995 to that in 2004?
Offer a very short reply. 0.49. What is the ratio of the Revenue generated (in %) in Middle East & North Africa (developing only) in 1995 to that in 2005?
Keep it short and to the point. 0.55. What is the ratio of the Revenue generated (in %) in Fiji in 1995 to that in 2005?
Your answer should be very brief. 0.78. What is the ratio of the Revenue generated (in %) of Seychelles in 1995 to that in 2005?
Keep it short and to the point. 0.13. What is the ratio of the Revenue generated (in %) of St. Vincent and the Grenadines in 1995 to that in 2005?
Provide a short and direct response. 0.49. What is the ratio of the Revenue generated (in %) of Middle East & North Africa (developing only) in 1996 to that in 2004?
Ensure brevity in your answer.  0.62. What is the ratio of the Revenue generated (in %) of Fiji in 1996 to that in 2004?
Provide a succinct answer. 0.79. What is the ratio of the Revenue generated (in %) in Seychelles in 1996 to that in 2004?
Your answer should be very brief. 0.2. What is the ratio of the Revenue generated (in %) of St. Vincent and the Grenadines in 1996 to that in 2004?
Offer a terse response. 0.5. What is the ratio of the Revenue generated (in %) in Middle East & North Africa (developing only) in 1996 to that in 2005?
Your answer should be compact. 0.6. What is the ratio of the Revenue generated (in %) of Fiji in 1996 to that in 2005?
Keep it short and to the point. 0.8. What is the ratio of the Revenue generated (in %) of Seychelles in 1996 to that in 2005?
Offer a very short reply. 0.22. What is the ratio of the Revenue generated (in %) of St. Vincent and the Grenadines in 1996 to that in 2005?
Offer a terse response. 0.5. What is the ratio of the Revenue generated (in %) in Middle East & North Africa (developing only) in 2004 to that in 2005?
Offer a terse response. 0.97. What is the ratio of the Revenue generated (in %) in Fiji in 2004 to that in 2005?
Ensure brevity in your answer.  1.02. What is the ratio of the Revenue generated (in %) of Seychelles in 2004 to that in 2005?
Make the answer very short. 1.08. What is the difference between the highest and the second highest Revenue generated (in %) in Middle East & North Africa (developing only)?
Offer a terse response. 0.8. What is the difference between the highest and the second highest Revenue generated (in %) in Fiji?
Make the answer very short. 0.86. What is the difference between the highest and the second highest Revenue generated (in %) in Seychelles?
Provide a short and direct response. 2.55. What is the difference between the highest and the second highest Revenue generated (in %) in St. Vincent and the Grenadines?
Your answer should be compact. 0. What is the difference between the highest and the lowest Revenue generated (in %) of Middle East & North Africa (developing only)?
Keep it short and to the point. 14.87. What is the difference between the highest and the lowest Revenue generated (in %) in Fiji?
Your answer should be compact. 9.68. What is the difference between the highest and the lowest Revenue generated (in %) in Seychelles?
Make the answer very short. 31.92. What is the difference between the highest and the lowest Revenue generated (in %) of St. Vincent and the Grenadines?
Your response must be concise. 11.07. 